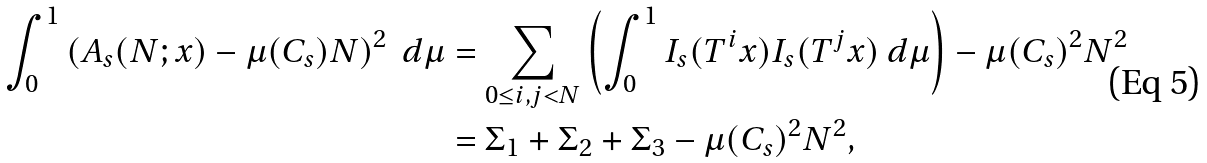<formula> <loc_0><loc_0><loc_500><loc_500>\int _ { 0 } ^ { 1 } \left ( A _ { s } ( N ; x ) - \mu ( C _ { s } ) N \right ) ^ { 2 } \ d \mu & = \sum _ { 0 \leq i , j < N } \left ( \int _ { 0 } ^ { 1 } I _ { s } ( T ^ { i } x ) I _ { s } ( T ^ { j } x ) \ d \mu \right ) - \mu ( C _ { s } ) ^ { 2 } N ^ { 2 } \\ & = \Sigma _ { 1 } + \Sigma _ { 2 } + \Sigma _ { 3 } - \mu ( C _ { s } ) ^ { 2 } N ^ { 2 } ,</formula> 